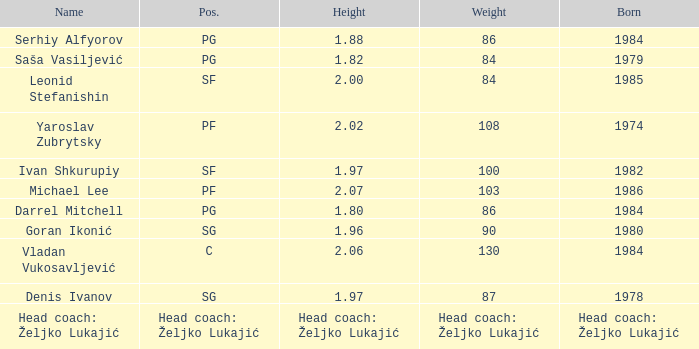What is the weight of the player with a height of 2.00m? 84.0. 